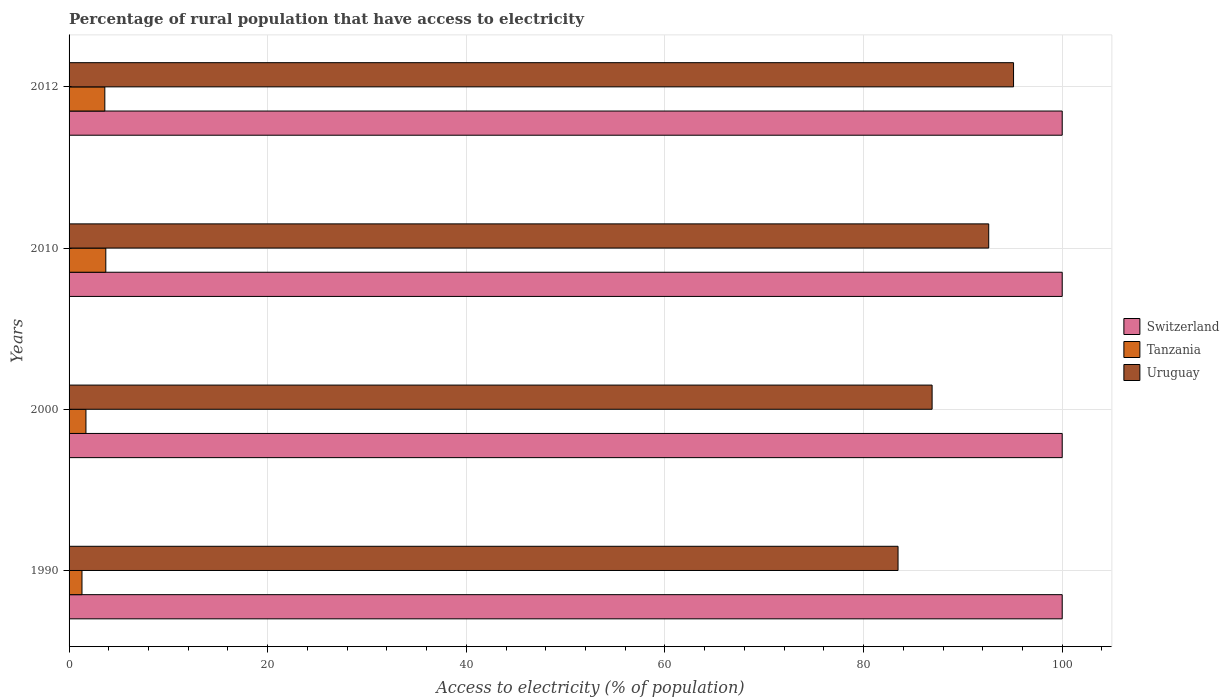How many different coloured bars are there?
Offer a terse response. 3. How many bars are there on the 2nd tick from the bottom?
Make the answer very short. 3. What is the label of the 4th group of bars from the top?
Your answer should be compact. 1990. In how many cases, is the number of bars for a given year not equal to the number of legend labels?
Provide a short and direct response. 0. What is the percentage of rural population that have access to electricity in Uruguay in 1990?
Offer a very short reply. 83.47. Across all years, what is the maximum percentage of rural population that have access to electricity in Uruguay?
Keep it short and to the point. 95.1. Across all years, what is the minimum percentage of rural population that have access to electricity in Switzerland?
Your response must be concise. 100. What is the difference between the percentage of rural population that have access to electricity in Tanzania in 1990 and that in 2010?
Make the answer very short. -2.4. What is the difference between the percentage of rural population that have access to electricity in Switzerland in 1990 and the percentage of rural population that have access to electricity in Uruguay in 2000?
Ensure brevity in your answer.  13.1. What is the average percentage of rural population that have access to electricity in Uruguay per year?
Offer a terse response. 89.52. In the year 1990, what is the difference between the percentage of rural population that have access to electricity in Switzerland and percentage of rural population that have access to electricity in Tanzania?
Your response must be concise. 98.7. Is the percentage of rural population that have access to electricity in Tanzania in 1990 less than that in 2010?
Provide a succinct answer. Yes. Is the difference between the percentage of rural population that have access to electricity in Switzerland in 2000 and 2010 greater than the difference between the percentage of rural population that have access to electricity in Tanzania in 2000 and 2010?
Your answer should be compact. Yes. What is the difference between the highest and the second highest percentage of rural population that have access to electricity in Switzerland?
Your answer should be very brief. 0. In how many years, is the percentage of rural population that have access to electricity in Uruguay greater than the average percentage of rural population that have access to electricity in Uruguay taken over all years?
Your answer should be compact. 2. What does the 2nd bar from the top in 2000 represents?
Your response must be concise. Tanzania. What does the 3rd bar from the bottom in 2012 represents?
Keep it short and to the point. Uruguay. Is it the case that in every year, the sum of the percentage of rural population that have access to electricity in Tanzania and percentage of rural population that have access to electricity in Switzerland is greater than the percentage of rural population that have access to electricity in Uruguay?
Offer a terse response. Yes. What is the difference between two consecutive major ticks on the X-axis?
Make the answer very short. 20. What is the title of the graph?
Ensure brevity in your answer.  Percentage of rural population that have access to electricity. What is the label or title of the X-axis?
Keep it short and to the point. Access to electricity (% of population). What is the label or title of the Y-axis?
Provide a short and direct response. Years. What is the Access to electricity (% of population) of Switzerland in 1990?
Offer a terse response. 100. What is the Access to electricity (% of population) of Uruguay in 1990?
Ensure brevity in your answer.  83.47. What is the Access to electricity (% of population) in Tanzania in 2000?
Offer a very short reply. 1.7. What is the Access to electricity (% of population) in Uruguay in 2000?
Provide a short and direct response. 86.9. What is the Access to electricity (% of population) in Tanzania in 2010?
Give a very brief answer. 3.7. What is the Access to electricity (% of population) of Uruguay in 2010?
Your answer should be very brief. 92.6. What is the Access to electricity (% of population) of Tanzania in 2012?
Your answer should be very brief. 3.6. What is the Access to electricity (% of population) in Uruguay in 2012?
Keep it short and to the point. 95.1. Across all years, what is the maximum Access to electricity (% of population) of Switzerland?
Your answer should be compact. 100. Across all years, what is the maximum Access to electricity (% of population) in Uruguay?
Ensure brevity in your answer.  95.1. Across all years, what is the minimum Access to electricity (% of population) of Switzerland?
Provide a short and direct response. 100. Across all years, what is the minimum Access to electricity (% of population) in Uruguay?
Offer a terse response. 83.47. What is the total Access to electricity (% of population) of Tanzania in the graph?
Offer a very short reply. 10.3. What is the total Access to electricity (% of population) in Uruguay in the graph?
Offer a terse response. 358.07. What is the difference between the Access to electricity (% of population) in Uruguay in 1990 and that in 2000?
Your response must be concise. -3.43. What is the difference between the Access to electricity (% of population) of Uruguay in 1990 and that in 2010?
Your answer should be very brief. -9.13. What is the difference between the Access to electricity (% of population) of Tanzania in 1990 and that in 2012?
Keep it short and to the point. -2.3. What is the difference between the Access to electricity (% of population) in Uruguay in 1990 and that in 2012?
Offer a very short reply. -11.63. What is the difference between the Access to electricity (% of population) in Switzerland in 2000 and that in 2010?
Your answer should be compact. 0. What is the difference between the Access to electricity (% of population) in Tanzania in 2000 and that in 2010?
Offer a very short reply. -2. What is the difference between the Access to electricity (% of population) of Uruguay in 2000 and that in 2012?
Give a very brief answer. -8.2. What is the difference between the Access to electricity (% of population) in Switzerland in 1990 and the Access to electricity (% of population) in Tanzania in 2000?
Make the answer very short. 98.3. What is the difference between the Access to electricity (% of population) in Tanzania in 1990 and the Access to electricity (% of population) in Uruguay in 2000?
Keep it short and to the point. -85.6. What is the difference between the Access to electricity (% of population) of Switzerland in 1990 and the Access to electricity (% of population) of Tanzania in 2010?
Make the answer very short. 96.3. What is the difference between the Access to electricity (% of population) of Switzerland in 1990 and the Access to electricity (% of population) of Uruguay in 2010?
Ensure brevity in your answer.  7.4. What is the difference between the Access to electricity (% of population) in Tanzania in 1990 and the Access to electricity (% of population) in Uruguay in 2010?
Offer a terse response. -91.3. What is the difference between the Access to electricity (% of population) in Switzerland in 1990 and the Access to electricity (% of population) in Tanzania in 2012?
Provide a short and direct response. 96.4. What is the difference between the Access to electricity (% of population) of Switzerland in 1990 and the Access to electricity (% of population) of Uruguay in 2012?
Give a very brief answer. 4.9. What is the difference between the Access to electricity (% of population) of Tanzania in 1990 and the Access to electricity (% of population) of Uruguay in 2012?
Your answer should be very brief. -93.8. What is the difference between the Access to electricity (% of population) in Switzerland in 2000 and the Access to electricity (% of population) in Tanzania in 2010?
Your response must be concise. 96.3. What is the difference between the Access to electricity (% of population) of Switzerland in 2000 and the Access to electricity (% of population) of Uruguay in 2010?
Offer a very short reply. 7.4. What is the difference between the Access to electricity (% of population) of Tanzania in 2000 and the Access to electricity (% of population) of Uruguay in 2010?
Provide a short and direct response. -90.9. What is the difference between the Access to electricity (% of population) of Switzerland in 2000 and the Access to electricity (% of population) of Tanzania in 2012?
Your answer should be compact. 96.4. What is the difference between the Access to electricity (% of population) of Tanzania in 2000 and the Access to electricity (% of population) of Uruguay in 2012?
Keep it short and to the point. -93.4. What is the difference between the Access to electricity (% of population) in Switzerland in 2010 and the Access to electricity (% of population) in Tanzania in 2012?
Ensure brevity in your answer.  96.4. What is the difference between the Access to electricity (% of population) of Tanzania in 2010 and the Access to electricity (% of population) of Uruguay in 2012?
Your response must be concise. -91.4. What is the average Access to electricity (% of population) in Switzerland per year?
Your response must be concise. 100. What is the average Access to electricity (% of population) in Tanzania per year?
Your answer should be very brief. 2.58. What is the average Access to electricity (% of population) in Uruguay per year?
Your answer should be very brief. 89.52. In the year 1990, what is the difference between the Access to electricity (% of population) in Switzerland and Access to electricity (% of population) in Tanzania?
Keep it short and to the point. 98.7. In the year 1990, what is the difference between the Access to electricity (% of population) of Switzerland and Access to electricity (% of population) of Uruguay?
Your response must be concise. 16.53. In the year 1990, what is the difference between the Access to electricity (% of population) of Tanzania and Access to electricity (% of population) of Uruguay?
Ensure brevity in your answer.  -82.17. In the year 2000, what is the difference between the Access to electricity (% of population) of Switzerland and Access to electricity (% of population) of Tanzania?
Offer a very short reply. 98.3. In the year 2000, what is the difference between the Access to electricity (% of population) of Tanzania and Access to electricity (% of population) of Uruguay?
Offer a terse response. -85.2. In the year 2010, what is the difference between the Access to electricity (% of population) of Switzerland and Access to electricity (% of population) of Tanzania?
Make the answer very short. 96.3. In the year 2010, what is the difference between the Access to electricity (% of population) of Switzerland and Access to electricity (% of population) of Uruguay?
Make the answer very short. 7.4. In the year 2010, what is the difference between the Access to electricity (% of population) of Tanzania and Access to electricity (% of population) of Uruguay?
Provide a short and direct response. -88.9. In the year 2012, what is the difference between the Access to electricity (% of population) in Switzerland and Access to electricity (% of population) in Tanzania?
Ensure brevity in your answer.  96.4. In the year 2012, what is the difference between the Access to electricity (% of population) in Switzerland and Access to electricity (% of population) in Uruguay?
Your answer should be compact. 4.9. In the year 2012, what is the difference between the Access to electricity (% of population) in Tanzania and Access to electricity (% of population) in Uruguay?
Give a very brief answer. -91.5. What is the ratio of the Access to electricity (% of population) of Switzerland in 1990 to that in 2000?
Offer a terse response. 1. What is the ratio of the Access to electricity (% of population) of Tanzania in 1990 to that in 2000?
Ensure brevity in your answer.  0.76. What is the ratio of the Access to electricity (% of population) in Uruguay in 1990 to that in 2000?
Your response must be concise. 0.96. What is the ratio of the Access to electricity (% of population) in Switzerland in 1990 to that in 2010?
Offer a very short reply. 1. What is the ratio of the Access to electricity (% of population) in Tanzania in 1990 to that in 2010?
Your answer should be very brief. 0.35. What is the ratio of the Access to electricity (% of population) of Uruguay in 1990 to that in 2010?
Offer a very short reply. 0.9. What is the ratio of the Access to electricity (% of population) in Tanzania in 1990 to that in 2012?
Your response must be concise. 0.36. What is the ratio of the Access to electricity (% of population) in Uruguay in 1990 to that in 2012?
Ensure brevity in your answer.  0.88. What is the ratio of the Access to electricity (% of population) of Tanzania in 2000 to that in 2010?
Your answer should be compact. 0.46. What is the ratio of the Access to electricity (% of population) of Uruguay in 2000 to that in 2010?
Keep it short and to the point. 0.94. What is the ratio of the Access to electricity (% of population) in Switzerland in 2000 to that in 2012?
Your answer should be compact. 1. What is the ratio of the Access to electricity (% of population) in Tanzania in 2000 to that in 2012?
Ensure brevity in your answer.  0.47. What is the ratio of the Access to electricity (% of population) in Uruguay in 2000 to that in 2012?
Provide a short and direct response. 0.91. What is the ratio of the Access to electricity (% of population) in Switzerland in 2010 to that in 2012?
Offer a very short reply. 1. What is the ratio of the Access to electricity (% of population) of Tanzania in 2010 to that in 2012?
Make the answer very short. 1.03. What is the ratio of the Access to electricity (% of population) of Uruguay in 2010 to that in 2012?
Your answer should be very brief. 0.97. What is the difference between the highest and the lowest Access to electricity (% of population) in Switzerland?
Make the answer very short. 0. What is the difference between the highest and the lowest Access to electricity (% of population) in Uruguay?
Your response must be concise. 11.63. 